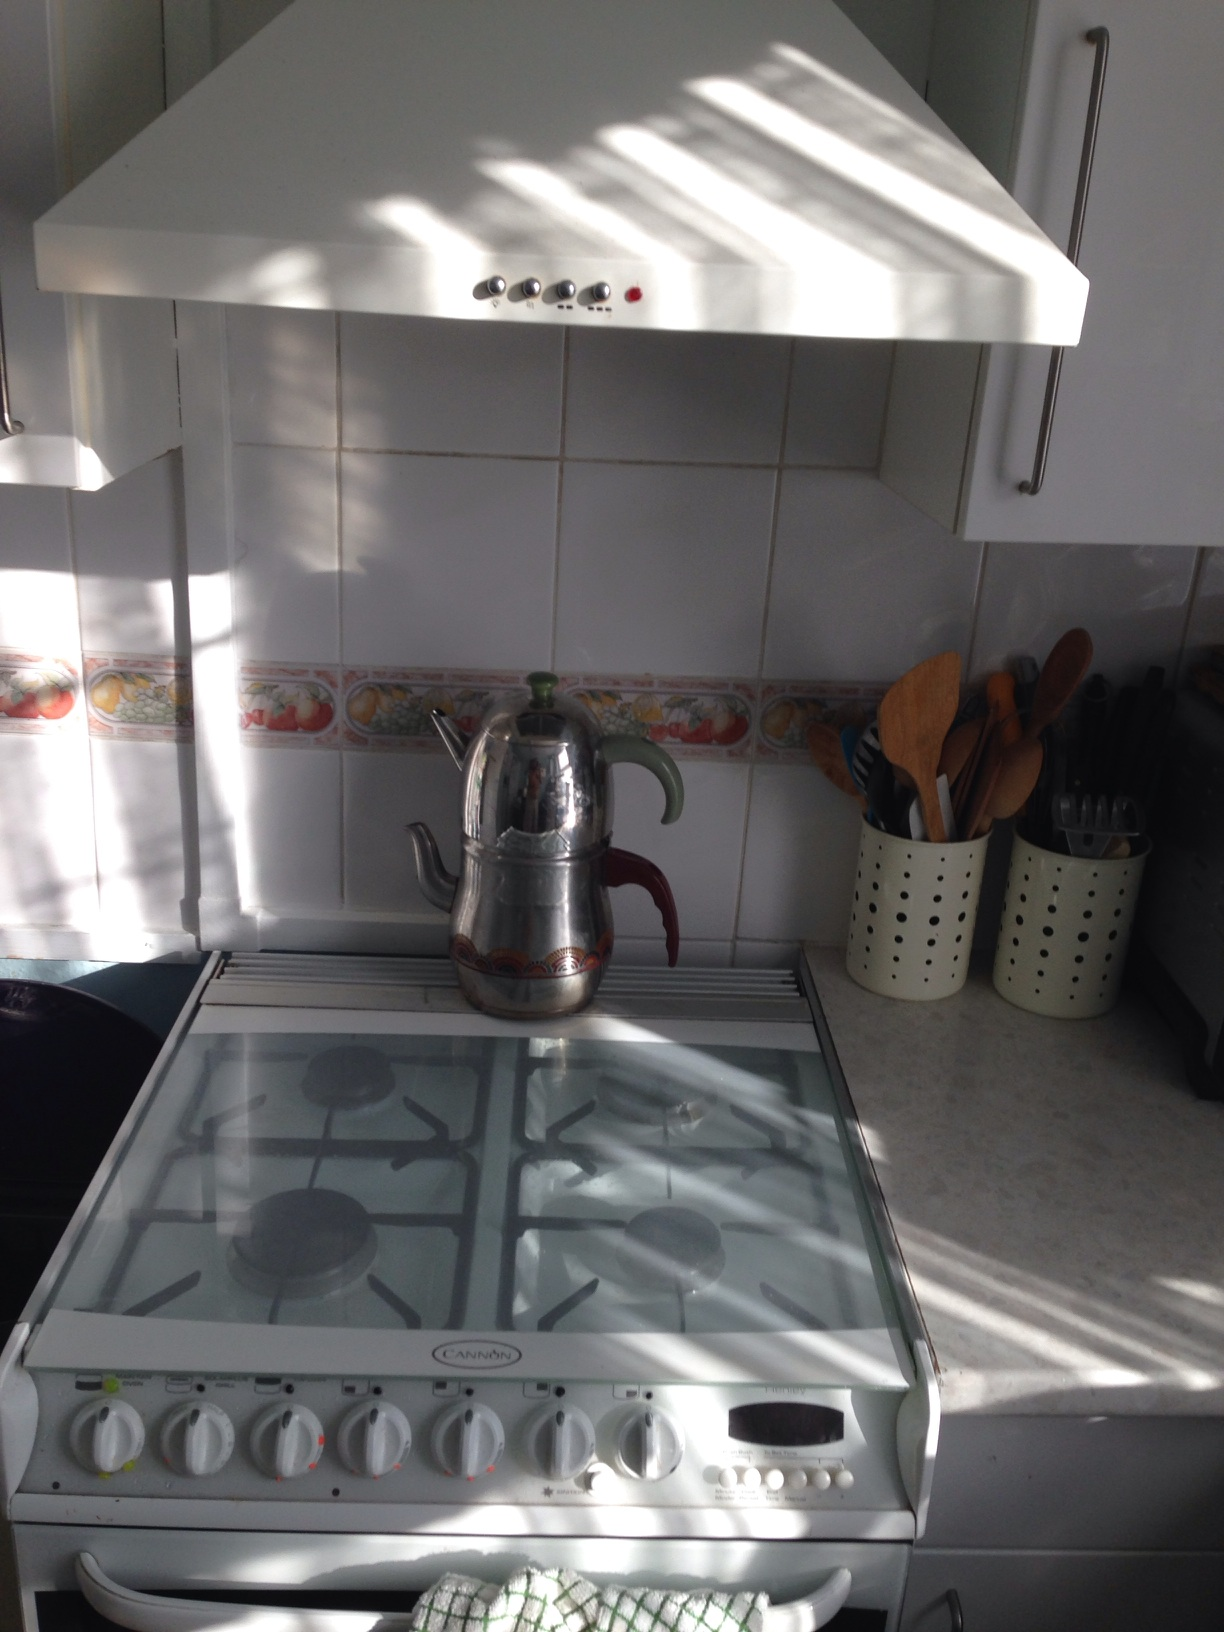Describe the scene in front of me please. The scene shows a section of a cozy kitchen. There is a white gas stove with four burners. On top of the stove, there is a stainless steel teapot. The stove is nestled between white cabinets, and there's a countertop to the right with containers holding various kitchen utensils like wooden spoons and spatulas. The backsplash has a decorative fruit border. The entire scene is bathed in natural light, creating a warm and welcoming atmosphere. 